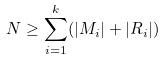Convert formula to latex. <formula><loc_0><loc_0><loc_500><loc_500>N \geq \sum _ { i = 1 } ^ { k } ( | M _ { i } | + | R _ { i } | )</formula> 